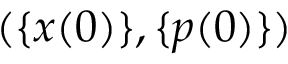Convert formula to latex. <formula><loc_0><loc_0><loc_500><loc_500>( \{ x ( 0 ) \} , \{ p ( 0 ) \} )</formula> 